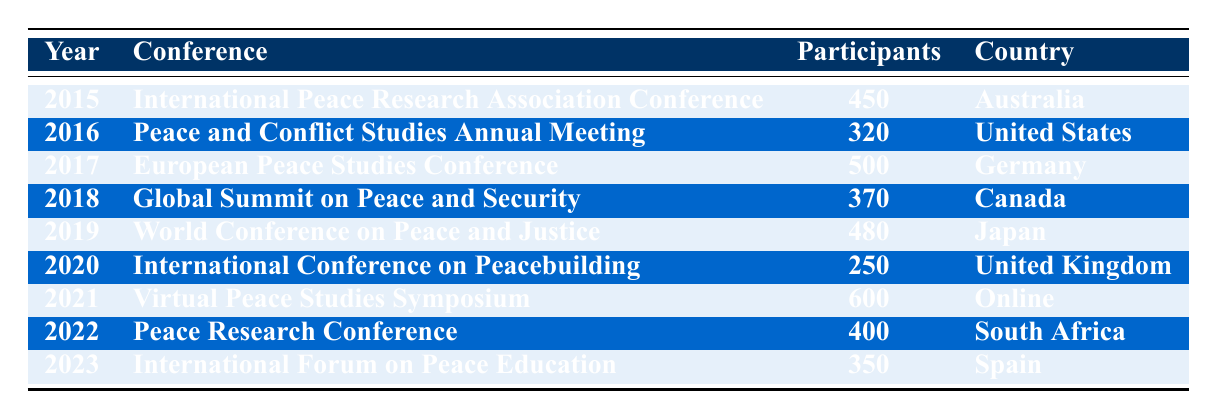What was the year with the highest number of participants in a peace studies conference? The row with the highest participant number is for the year 2021, where 600 participants attended the Virtual Peace Studies Symposium.
Answer: 2021 Which conference had the least number of participants and in what year? Referring to the table, the International Conference on Peacebuilding in 2020 had the least participants, with only 250 attendees.
Answer: 250 in 2020 What is the total number of participants across all conferences from 2015 to 2023? To find the total, we sum the participants from all rows: 450 + 320 + 500 + 370 + 480 + 250 + 600 + 400 + 350 = 4000.
Answer: 4000 Was the number of participants in 2017 greater than in 2018? In 2017, there were 500 participants, while in 2018, there were 370 participants. Therefore, it is true that 2017 had more participants than 2018.
Answer: Yes What is the average number of participants from 2016 to 2020? The participants from 2016 to 2020 are 320, 500, 370, 480, and 250. Their total is 320 + 500 + 370 + 480 + 250 = 1920. There are 5 years, so the average is 1920 / 5 = 384.
Answer: 384 How many countries hosted the peace studies conferences between 2015 and 2023? The unique countries listed are Australia, United States, Germany, Canada, Japan, United Kingdom, Online, South Africa, and Spain, resulting in a total of 9 unique countries.
Answer: 9 Did the number of participants increase from 2019 to 2020? In 2019, there were 480 participants, and in 2020, there were 250 participants. This indicates a decrease from 2019 to 2020.
Answer: No In which year did the European Peace Studies Conference take place? The European Peace Studies Conference is specifically listed in the year 2017 with 500 participants.
Answer: 2017 What was the change in the number of participants from the conference in 2015 to the conference in 2023? The conference in 2015 had 450 participants while the 2023 conference had 350 participants. Therefore, there was a decrease of 450 - 350 = 100 participants from 2015 to 2023.
Answer: 100 decrease 